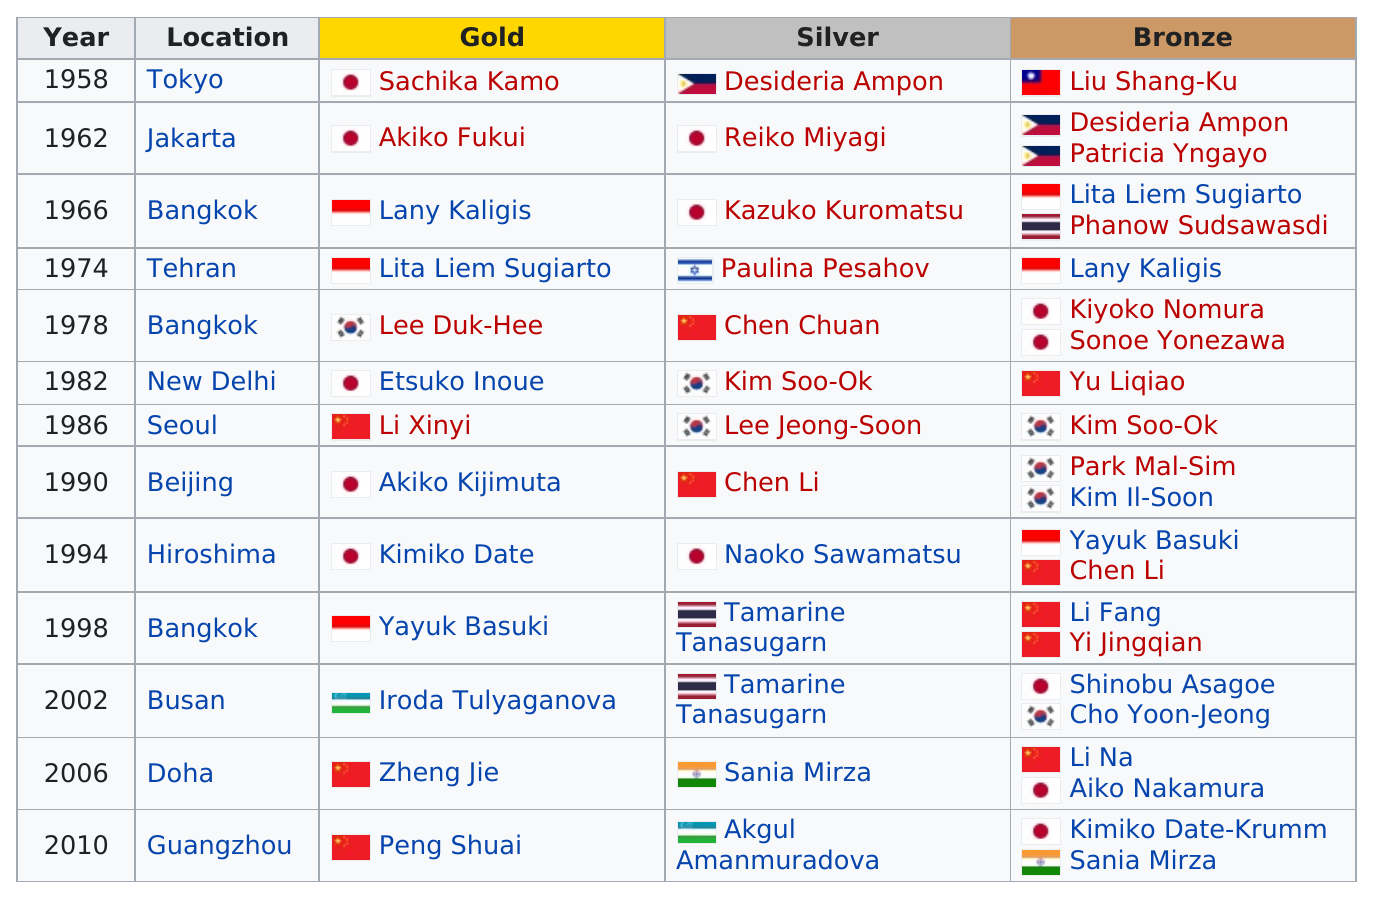Specify some key components in this picture. Yu Liqiao was the only person to win a bronze medal in the singles event at the 1982 New Delhi Olympics. Contestants from Japan won a total of three silver medals. Japan has won gold at the Olympics five times. Desideria Ampon won the bronze medal in the same year as Patricia Yngayo. Etsuko Inoue was the next female tennis player to win a tournament after Lee Duk-hee. 